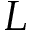Convert formula to latex. <formula><loc_0><loc_0><loc_500><loc_500>L</formula> 